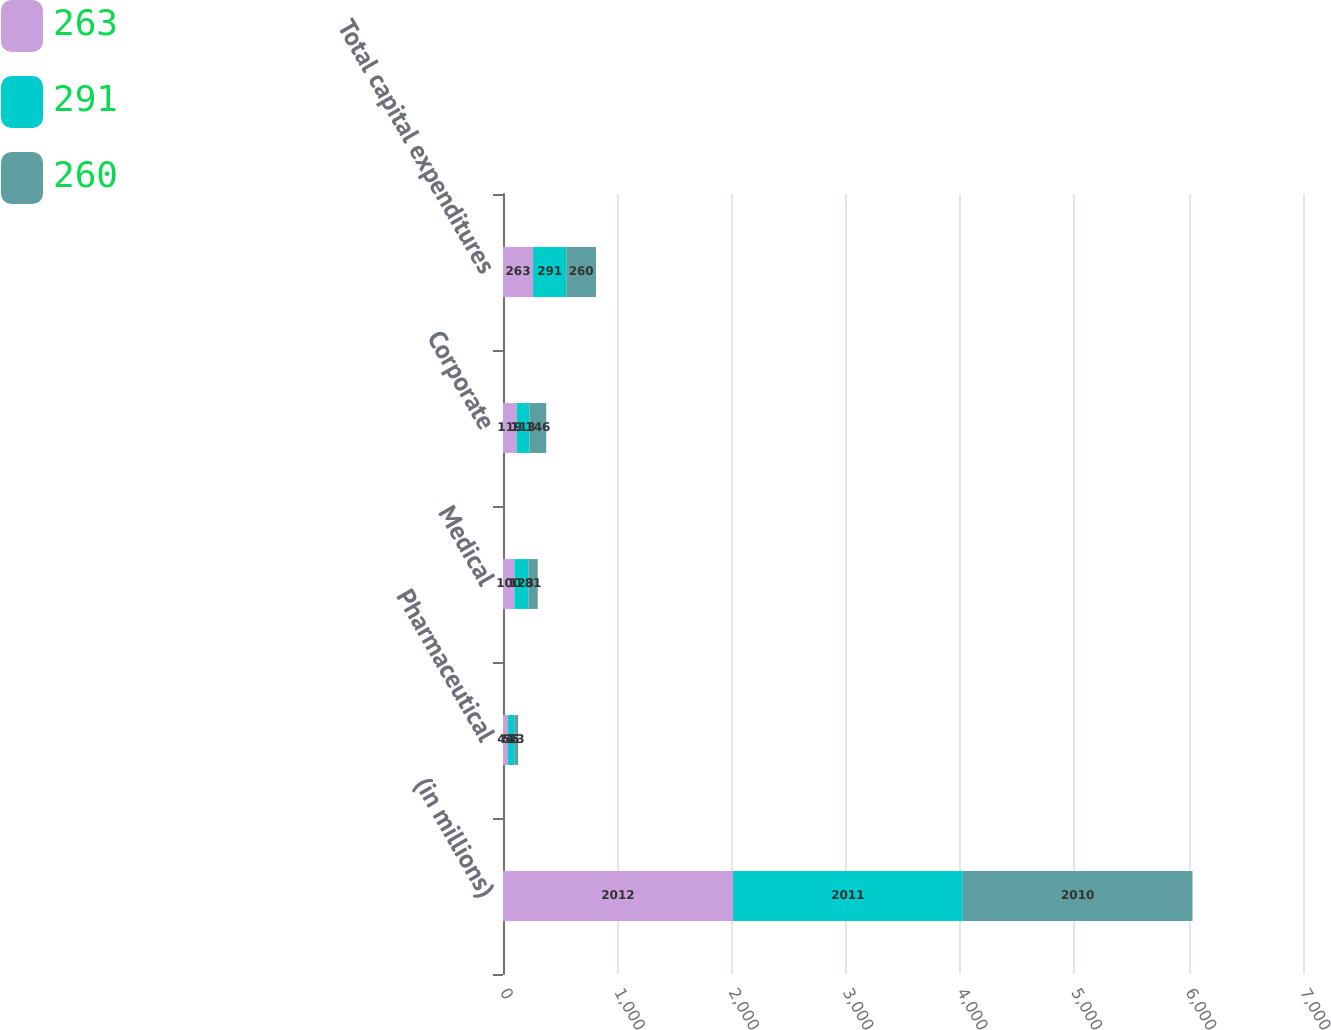<chart> <loc_0><loc_0><loc_500><loc_500><stacked_bar_chart><ecel><fcel>(in millions)<fcel>Pharmaceutical<fcel>Medical<fcel>Corporate<fcel>Total capital expenditures<nl><fcel>263<fcel>2012<fcel>44<fcel>100<fcel>119<fcel>263<nl><fcel>291<fcel>2011<fcel>55<fcel>123<fcel>113<fcel>291<nl><fcel>260<fcel>2010<fcel>33<fcel>81<fcel>146<fcel>260<nl></chart> 